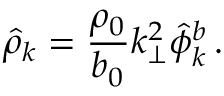Convert formula to latex. <formula><loc_0><loc_0><loc_500><loc_500>\hat { \rho } _ { k } = \frac { \rho _ { 0 } } { b _ { 0 } } k _ { \perp } ^ { 2 } \hat { \phi } _ { k } ^ { b } \, .</formula> 